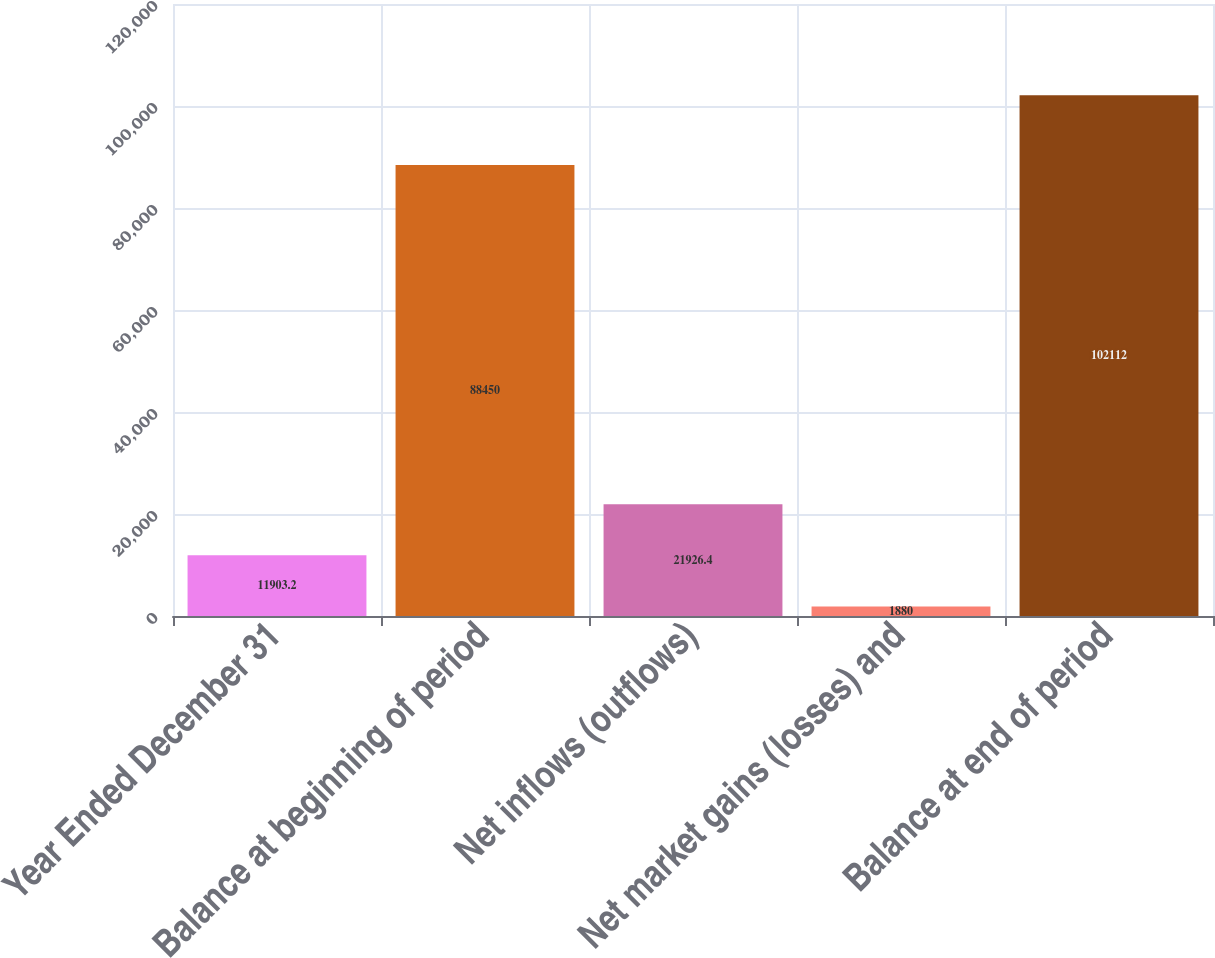<chart> <loc_0><loc_0><loc_500><loc_500><bar_chart><fcel>Year Ended December 31<fcel>Balance at beginning of period<fcel>Net inflows (outflows)<fcel>Net market gains (losses) and<fcel>Balance at end of period<nl><fcel>11903.2<fcel>88450<fcel>21926.4<fcel>1880<fcel>102112<nl></chart> 